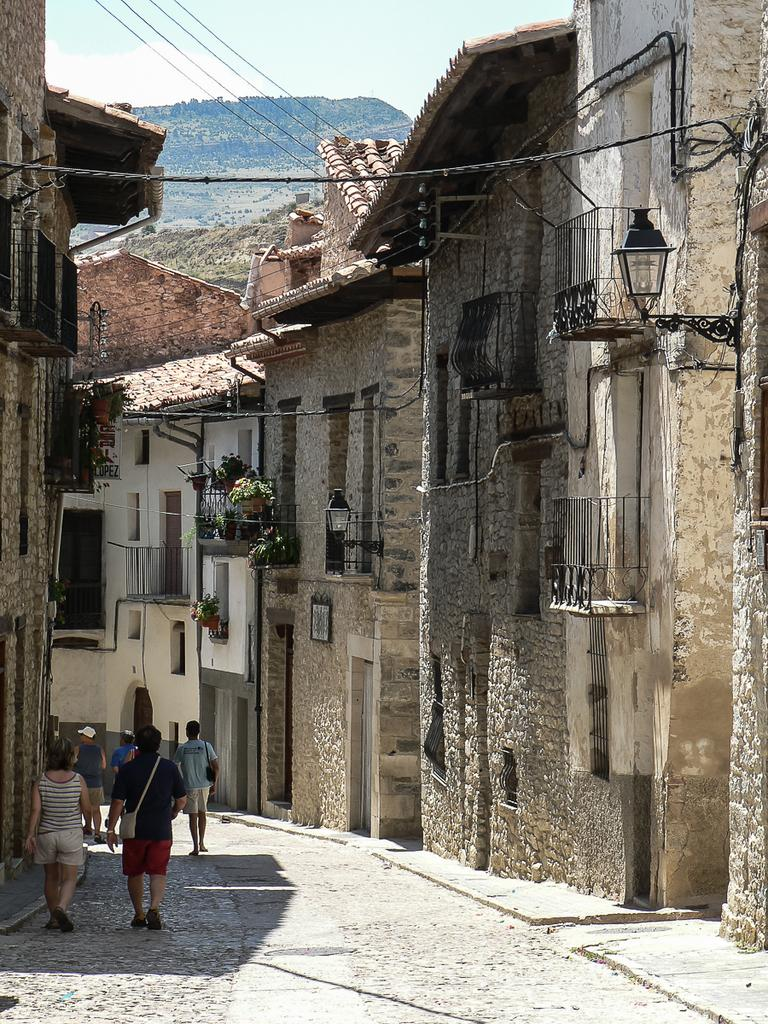What type of structures can be seen in the image? There are buildings in the image. What other elements are present in the image besides buildings? There are plants and people visible on the road in the image. What is the representative of the plants doing in the image? There is no representative present in the image; it is a picture of plants and other elements. 